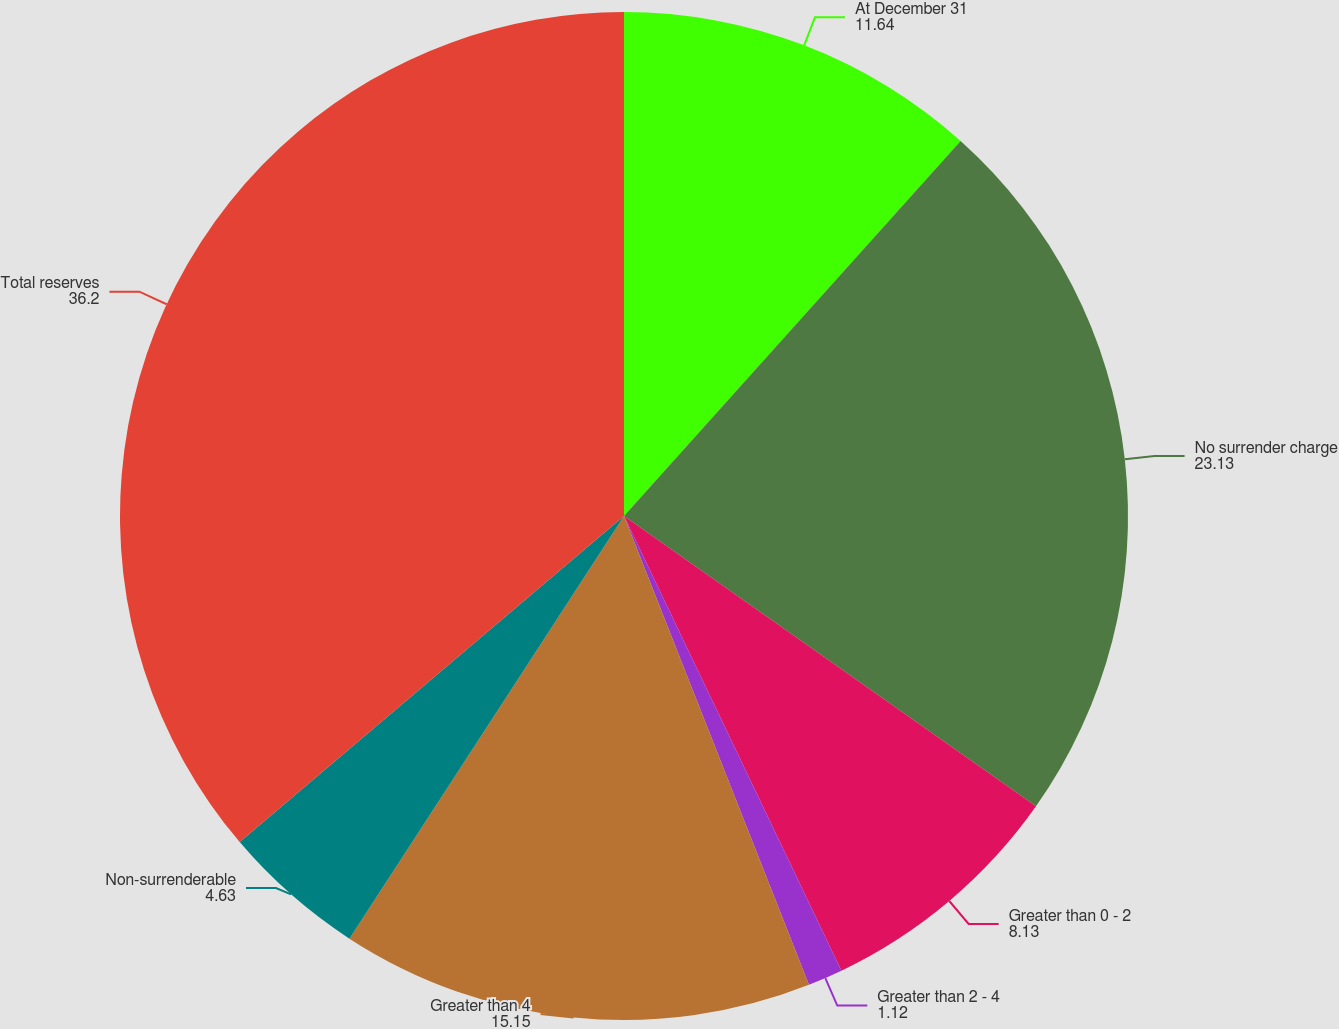Convert chart. <chart><loc_0><loc_0><loc_500><loc_500><pie_chart><fcel>At December 31<fcel>No surrender charge<fcel>Greater than 0 - 2<fcel>Greater than 2 - 4<fcel>Greater than 4<fcel>Non-surrenderable<fcel>Total reserves<nl><fcel>11.64%<fcel>23.13%<fcel>8.13%<fcel>1.12%<fcel>15.15%<fcel>4.63%<fcel>36.2%<nl></chart> 